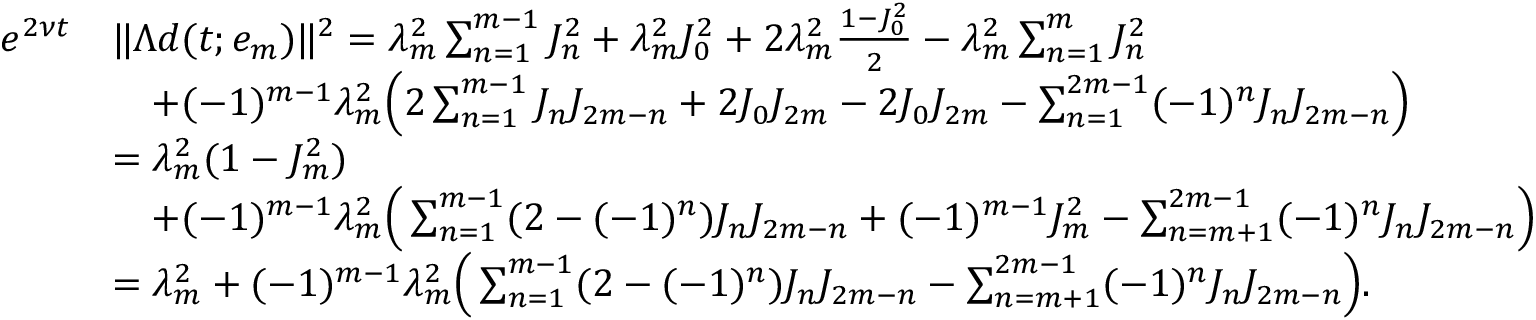<formula> <loc_0><loc_0><loc_500><loc_500>\begin{array} { r l } { e ^ { 2 \nu t } } & { \| \Lambda d ( t ; e _ { m } ) \| ^ { 2 } = \lambda _ { m } ^ { 2 } \sum _ { n = 1 } ^ { m - 1 } J _ { n } ^ { 2 } + \lambda _ { m } ^ { 2 } J _ { 0 } ^ { 2 } + 2 \lambda _ { m } ^ { 2 } \frac { 1 - J _ { 0 } ^ { 2 } } { 2 } - \lambda _ { m } ^ { 2 } \sum _ { n = 1 } ^ { m } J _ { n } ^ { 2 } } \\ & { \quad + ( - 1 ) ^ { m - 1 } \lambda _ { m } ^ { 2 } \left ( 2 \sum _ { n = 1 } ^ { m - 1 } J _ { n } J _ { 2 m - n } + 2 J _ { 0 } J _ { 2 m } - 2 J _ { 0 } J _ { 2 m } - \sum _ { n = 1 } ^ { 2 m - 1 } ( - 1 ) ^ { n } J _ { n } J _ { 2 m - n } \right ) } \\ & { = \lambda _ { m } ^ { 2 } ( 1 - J _ { m } ^ { 2 } ) } \\ & { \quad + ( - 1 ) ^ { m - 1 } \lambda _ { m } ^ { 2 } \left ( \sum _ { n = 1 } ^ { m - 1 } ( 2 - ( - 1 ) ^ { n } ) J _ { n } J _ { 2 m - n } + ( - 1 ) ^ { m - 1 } J _ { m } ^ { 2 } - \sum _ { n = m + 1 } ^ { 2 m - 1 } ( - 1 ) ^ { n } J _ { n } J _ { 2 m - n } \right ) } \\ & { = \lambda _ { m } ^ { 2 } + ( - 1 ) ^ { m - 1 } \lambda _ { m } ^ { 2 } \left ( \sum _ { n = 1 } ^ { m - 1 } ( 2 - ( - 1 ) ^ { n } ) J _ { n } J _ { 2 m - n } - \sum _ { n = m + 1 } ^ { 2 m - 1 } ( - 1 ) ^ { n } J _ { n } J _ { 2 m - n } \right ) . } \end{array}</formula> 